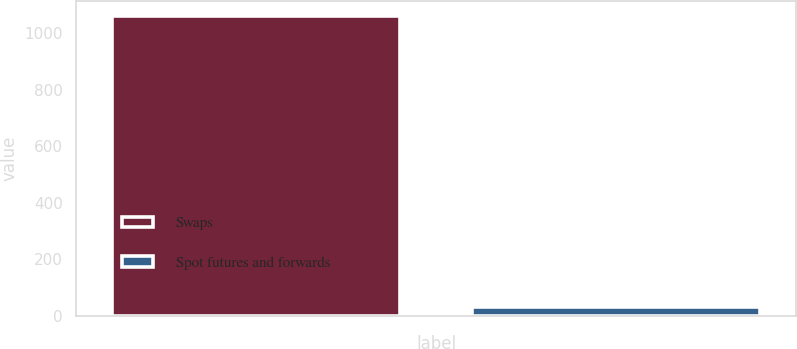Convert chart to OTSL. <chart><loc_0><loc_0><loc_500><loc_500><bar_chart><fcel>Swaps<fcel>Spot futures and forwards<nl><fcel>1062.6<fcel>30.5<nl></chart> 